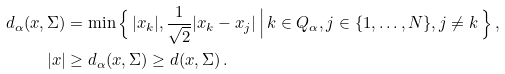<formula> <loc_0><loc_0><loc_500><loc_500>d _ { \alpha } ( { x } , \Sigma ) & = \min \Big \{ \, | x _ { k } | , \frac { 1 } { \sqrt { 2 } } | x _ { k } - x _ { j } | \, \Big | \, k \in Q _ { \alpha } , j \in \{ 1 , \dots , N \} , j \neq k \, \Big \} \, , \\ | { x } | & \geq d _ { \alpha } ( { x } , \Sigma ) \geq d ( { x } , \Sigma ) \, .</formula> 